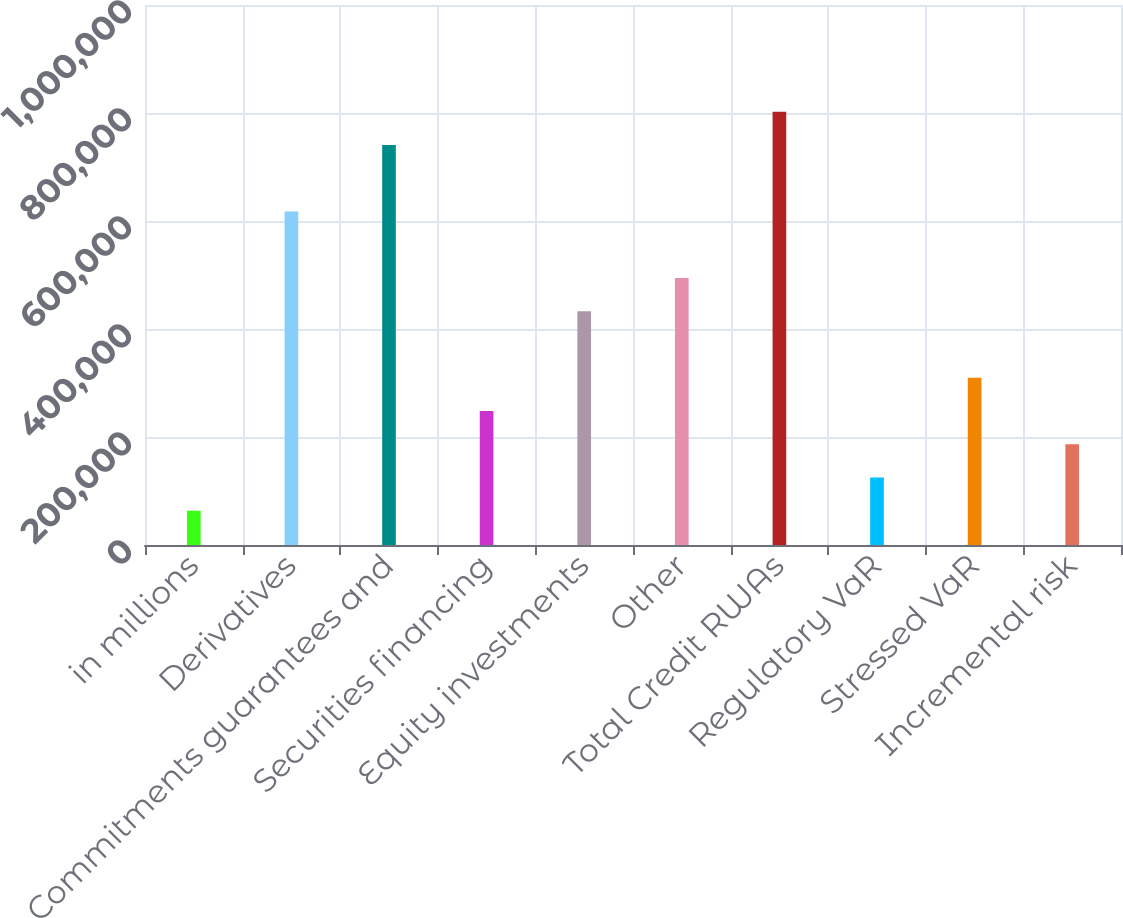Convert chart to OTSL. <chart><loc_0><loc_0><loc_500><loc_500><bar_chart><fcel>in millions<fcel>Derivatives<fcel>Commitments guarantees and<fcel>Securities financing<fcel>Equity investments<fcel>Other<fcel>Total Credit RWAs<fcel>Regulatory VaR<fcel>Stressed VaR<fcel>Incremental risk<nl><fcel>63447.6<fcel>617646<fcel>740801<fcel>248180<fcel>432913<fcel>494491<fcel>802379<fcel>125025<fcel>309758<fcel>186603<nl></chart> 